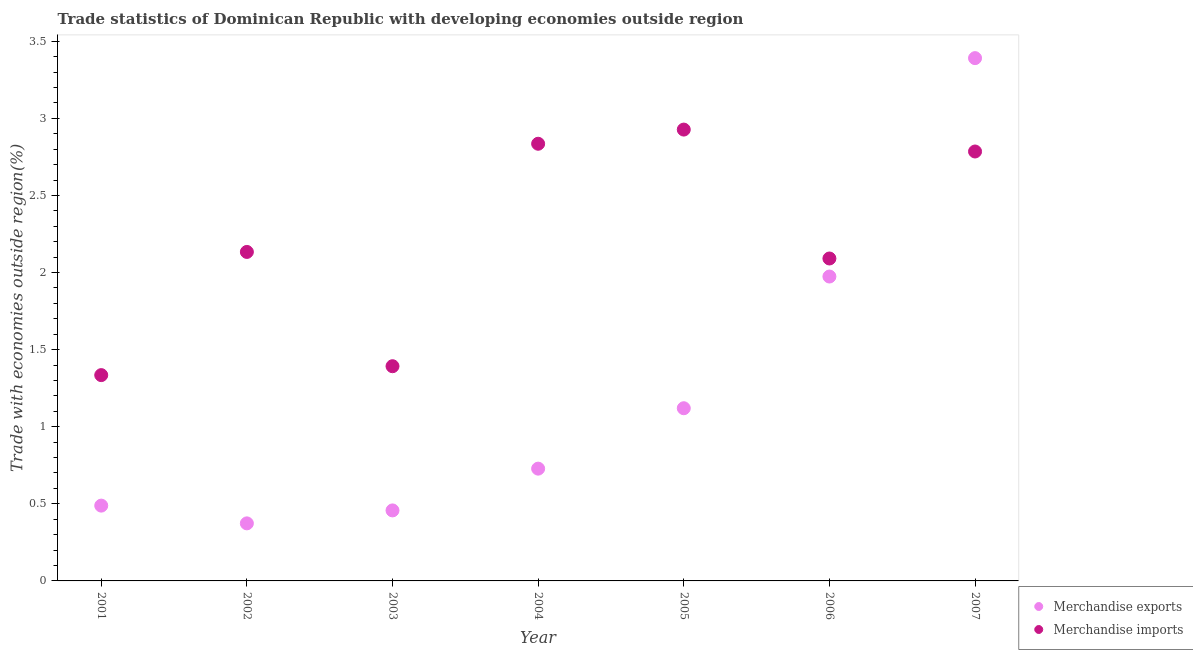How many different coloured dotlines are there?
Offer a terse response. 2. What is the merchandise imports in 2007?
Your answer should be very brief. 2.79. Across all years, what is the maximum merchandise imports?
Offer a terse response. 2.93. Across all years, what is the minimum merchandise exports?
Provide a short and direct response. 0.37. In which year was the merchandise exports minimum?
Your answer should be very brief. 2002. What is the total merchandise exports in the graph?
Keep it short and to the point. 8.53. What is the difference between the merchandise exports in 2004 and that in 2007?
Your answer should be compact. -2.66. What is the difference between the merchandise imports in 2002 and the merchandise exports in 2004?
Your response must be concise. 1.41. What is the average merchandise exports per year?
Your answer should be compact. 1.22. In the year 2001, what is the difference between the merchandise imports and merchandise exports?
Give a very brief answer. 0.85. What is the ratio of the merchandise exports in 2001 to that in 2006?
Ensure brevity in your answer.  0.25. Is the merchandise imports in 2003 less than that in 2005?
Your answer should be compact. Yes. Is the difference between the merchandise imports in 2003 and 2005 greater than the difference between the merchandise exports in 2003 and 2005?
Ensure brevity in your answer.  No. What is the difference between the highest and the second highest merchandise exports?
Provide a succinct answer. 1.42. What is the difference between the highest and the lowest merchandise exports?
Provide a short and direct response. 3.02. In how many years, is the merchandise exports greater than the average merchandise exports taken over all years?
Provide a short and direct response. 2. Is the sum of the merchandise exports in 2002 and 2007 greater than the maximum merchandise imports across all years?
Ensure brevity in your answer.  Yes. Does the merchandise exports monotonically increase over the years?
Keep it short and to the point. No. Is the merchandise imports strictly less than the merchandise exports over the years?
Keep it short and to the point. No. What is the difference between two consecutive major ticks on the Y-axis?
Offer a very short reply. 0.5. Are the values on the major ticks of Y-axis written in scientific E-notation?
Your answer should be compact. No. Does the graph contain grids?
Offer a terse response. No. How many legend labels are there?
Your answer should be compact. 2. What is the title of the graph?
Your response must be concise. Trade statistics of Dominican Republic with developing economies outside region. What is the label or title of the X-axis?
Your answer should be compact. Year. What is the label or title of the Y-axis?
Ensure brevity in your answer.  Trade with economies outside region(%). What is the Trade with economies outside region(%) in Merchandise exports in 2001?
Offer a very short reply. 0.49. What is the Trade with economies outside region(%) of Merchandise imports in 2001?
Your response must be concise. 1.33. What is the Trade with economies outside region(%) in Merchandise exports in 2002?
Your response must be concise. 0.37. What is the Trade with economies outside region(%) in Merchandise imports in 2002?
Your answer should be compact. 2.13. What is the Trade with economies outside region(%) in Merchandise exports in 2003?
Provide a short and direct response. 0.46. What is the Trade with economies outside region(%) of Merchandise imports in 2003?
Give a very brief answer. 1.39. What is the Trade with economies outside region(%) of Merchandise exports in 2004?
Offer a terse response. 0.73. What is the Trade with economies outside region(%) of Merchandise imports in 2004?
Give a very brief answer. 2.84. What is the Trade with economies outside region(%) of Merchandise exports in 2005?
Keep it short and to the point. 1.12. What is the Trade with economies outside region(%) in Merchandise imports in 2005?
Your response must be concise. 2.93. What is the Trade with economies outside region(%) of Merchandise exports in 2006?
Your answer should be compact. 1.97. What is the Trade with economies outside region(%) in Merchandise imports in 2006?
Offer a terse response. 2.09. What is the Trade with economies outside region(%) in Merchandise exports in 2007?
Your answer should be very brief. 3.39. What is the Trade with economies outside region(%) of Merchandise imports in 2007?
Your answer should be compact. 2.79. Across all years, what is the maximum Trade with economies outside region(%) in Merchandise exports?
Offer a terse response. 3.39. Across all years, what is the maximum Trade with economies outside region(%) in Merchandise imports?
Your answer should be very brief. 2.93. Across all years, what is the minimum Trade with economies outside region(%) of Merchandise exports?
Your answer should be compact. 0.37. Across all years, what is the minimum Trade with economies outside region(%) in Merchandise imports?
Keep it short and to the point. 1.33. What is the total Trade with economies outside region(%) of Merchandise exports in the graph?
Your answer should be very brief. 8.53. What is the total Trade with economies outside region(%) of Merchandise imports in the graph?
Provide a short and direct response. 15.5. What is the difference between the Trade with economies outside region(%) of Merchandise exports in 2001 and that in 2002?
Offer a very short reply. 0.12. What is the difference between the Trade with economies outside region(%) in Merchandise imports in 2001 and that in 2002?
Keep it short and to the point. -0.8. What is the difference between the Trade with economies outside region(%) in Merchandise exports in 2001 and that in 2003?
Provide a succinct answer. 0.03. What is the difference between the Trade with economies outside region(%) in Merchandise imports in 2001 and that in 2003?
Your answer should be very brief. -0.06. What is the difference between the Trade with economies outside region(%) in Merchandise exports in 2001 and that in 2004?
Make the answer very short. -0.24. What is the difference between the Trade with economies outside region(%) in Merchandise imports in 2001 and that in 2004?
Offer a terse response. -1.5. What is the difference between the Trade with economies outside region(%) of Merchandise exports in 2001 and that in 2005?
Your response must be concise. -0.63. What is the difference between the Trade with economies outside region(%) in Merchandise imports in 2001 and that in 2005?
Provide a short and direct response. -1.59. What is the difference between the Trade with economies outside region(%) of Merchandise exports in 2001 and that in 2006?
Offer a terse response. -1.49. What is the difference between the Trade with economies outside region(%) in Merchandise imports in 2001 and that in 2006?
Provide a succinct answer. -0.76. What is the difference between the Trade with economies outside region(%) in Merchandise exports in 2001 and that in 2007?
Give a very brief answer. -2.9. What is the difference between the Trade with economies outside region(%) in Merchandise imports in 2001 and that in 2007?
Make the answer very short. -1.45. What is the difference between the Trade with economies outside region(%) of Merchandise exports in 2002 and that in 2003?
Offer a terse response. -0.08. What is the difference between the Trade with economies outside region(%) in Merchandise imports in 2002 and that in 2003?
Give a very brief answer. 0.74. What is the difference between the Trade with economies outside region(%) of Merchandise exports in 2002 and that in 2004?
Offer a terse response. -0.35. What is the difference between the Trade with economies outside region(%) in Merchandise imports in 2002 and that in 2004?
Your answer should be compact. -0.7. What is the difference between the Trade with economies outside region(%) in Merchandise exports in 2002 and that in 2005?
Provide a succinct answer. -0.75. What is the difference between the Trade with economies outside region(%) in Merchandise imports in 2002 and that in 2005?
Your answer should be compact. -0.79. What is the difference between the Trade with economies outside region(%) of Merchandise exports in 2002 and that in 2006?
Ensure brevity in your answer.  -1.6. What is the difference between the Trade with economies outside region(%) in Merchandise imports in 2002 and that in 2006?
Your answer should be very brief. 0.04. What is the difference between the Trade with economies outside region(%) of Merchandise exports in 2002 and that in 2007?
Provide a succinct answer. -3.02. What is the difference between the Trade with economies outside region(%) in Merchandise imports in 2002 and that in 2007?
Your answer should be compact. -0.65. What is the difference between the Trade with economies outside region(%) of Merchandise exports in 2003 and that in 2004?
Offer a very short reply. -0.27. What is the difference between the Trade with economies outside region(%) of Merchandise imports in 2003 and that in 2004?
Offer a very short reply. -1.44. What is the difference between the Trade with economies outside region(%) of Merchandise exports in 2003 and that in 2005?
Your response must be concise. -0.66. What is the difference between the Trade with economies outside region(%) of Merchandise imports in 2003 and that in 2005?
Offer a very short reply. -1.53. What is the difference between the Trade with economies outside region(%) in Merchandise exports in 2003 and that in 2006?
Make the answer very short. -1.52. What is the difference between the Trade with economies outside region(%) of Merchandise imports in 2003 and that in 2006?
Keep it short and to the point. -0.7. What is the difference between the Trade with economies outside region(%) of Merchandise exports in 2003 and that in 2007?
Your response must be concise. -2.93. What is the difference between the Trade with economies outside region(%) of Merchandise imports in 2003 and that in 2007?
Keep it short and to the point. -1.39. What is the difference between the Trade with economies outside region(%) in Merchandise exports in 2004 and that in 2005?
Ensure brevity in your answer.  -0.39. What is the difference between the Trade with economies outside region(%) of Merchandise imports in 2004 and that in 2005?
Ensure brevity in your answer.  -0.09. What is the difference between the Trade with economies outside region(%) of Merchandise exports in 2004 and that in 2006?
Provide a short and direct response. -1.25. What is the difference between the Trade with economies outside region(%) in Merchandise imports in 2004 and that in 2006?
Ensure brevity in your answer.  0.74. What is the difference between the Trade with economies outside region(%) in Merchandise exports in 2004 and that in 2007?
Provide a short and direct response. -2.66. What is the difference between the Trade with economies outside region(%) in Merchandise imports in 2004 and that in 2007?
Keep it short and to the point. 0.05. What is the difference between the Trade with economies outside region(%) in Merchandise exports in 2005 and that in 2006?
Provide a succinct answer. -0.85. What is the difference between the Trade with economies outside region(%) in Merchandise imports in 2005 and that in 2006?
Offer a terse response. 0.84. What is the difference between the Trade with economies outside region(%) in Merchandise exports in 2005 and that in 2007?
Provide a succinct answer. -2.27. What is the difference between the Trade with economies outside region(%) in Merchandise imports in 2005 and that in 2007?
Ensure brevity in your answer.  0.14. What is the difference between the Trade with economies outside region(%) in Merchandise exports in 2006 and that in 2007?
Offer a terse response. -1.42. What is the difference between the Trade with economies outside region(%) of Merchandise imports in 2006 and that in 2007?
Make the answer very short. -0.69. What is the difference between the Trade with economies outside region(%) in Merchandise exports in 2001 and the Trade with economies outside region(%) in Merchandise imports in 2002?
Ensure brevity in your answer.  -1.65. What is the difference between the Trade with economies outside region(%) of Merchandise exports in 2001 and the Trade with economies outside region(%) of Merchandise imports in 2003?
Keep it short and to the point. -0.9. What is the difference between the Trade with economies outside region(%) in Merchandise exports in 2001 and the Trade with economies outside region(%) in Merchandise imports in 2004?
Keep it short and to the point. -2.35. What is the difference between the Trade with economies outside region(%) in Merchandise exports in 2001 and the Trade with economies outside region(%) in Merchandise imports in 2005?
Provide a succinct answer. -2.44. What is the difference between the Trade with economies outside region(%) in Merchandise exports in 2001 and the Trade with economies outside region(%) in Merchandise imports in 2006?
Offer a terse response. -1.6. What is the difference between the Trade with economies outside region(%) of Merchandise exports in 2001 and the Trade with economies outside region(%) of Merchandise imports in 2007?
Your response must be concise. -2.3. What is the difference between the Trade with economies outside region(%) in Merchandise exports in 2002 and the Trade with economies outside region(%) in Merchandise imports in 2003?
Make the answer very short. -1.02. What is the difference between the Trade with economies outside region(%) in Merchandise exports in 2002 and the Trade with economies outside region(%) in Merchandise imports in 2004?
Ensure brevity in your answer.  -2.46. What is the difference between the Trade with economies outside region(%) of Merchandise exports in 2002 and the Trade with economies outside region(%) of Merchandise imports in 2005?
Keep it short and to the point. -2.55. What is the difference between the Trade with economies outside region(%) of Merchandise exports in 2002 and the Trade with economies outside region(%) of Merchandise imports in 2006?
Ensure brevity in your answer.  -1.72. What is the difference between the Trade with economies outside region(%) of Merchandise exports in 2002 and the Trade with economies outside region(%) of Merchandise imports in 2007?
Provide a succinct answer. -2.41. What is the difference between the Trade with economies outside region(%) in Merchandise exports in 2003 and the Trade with economies outside region(%) in Merchandise imports in 2004?
Your response must be concise. -2.38. What is the difference between the Trade with economies outside region(%) in Merchandise exports in 2003 and the Trade with economies outside region(%) in Merchandise imports in 2005?
Your response must be concise. -2.47. What is the difference between the Trade with economies outside region(%) of Merchandise exports in 2003 and the Trade with economies outside region(%) of Merchandise imports in 2006?
Your answer should be compact. -1.63. What is the difference between the Trade with economies outside region(%) of Merchandise exports in 2003 and the Trade with economies outside region(%) of Merchandise imports in 2007?
Make the answer very short. -2.33. What is the difference between the Trade with economies outside region(%) of Merchandise exports in 2004 and the Trade with economies outside region(%) of Merchandise imports in 2005?
Offer a very short reply. -2.2. What is the difference between the Trade with economies outside region(%) of Merchandise exports in 2004 and the Trade with economies outside region(%) of Merchandise imports in 2006?
Keep it short and to the point. -1.36. What is the difference between the Trade with economies outside region(%) in Merchandise exports in 2004 and the Trade with economies outside region(%) in Merchandise imports in 2007?
Make the answer very short. -2.06. What is the difference between the Trade with economies outside region(%) in Merchandise exports in 2005 and the Trade with economies outside region(%) in Merchandise imports in 2006?
Your answer should be very brief. -0.97. What is the difference between the Trade with economies outside region(%) of Merchandise exports in 2005 and the Trade with economies outside region(%) of Merchandise imports in 2007?
Give a very brief answer. -1.67. What is the difference between the Trade with economies outside region(%) of Merchandise exports in 2006 and the Trade with economies outside region(%) of Merchandise imports in 2007?
Provide a succinct answer. -0.81. What is the average Trade with economies outside region(%) of Merchandise exports per year?
Offer a terse response. 1.22. What is the average Trade with economies outside region(%) in Merchandise imports per year?
Offer a terse response. 2.21. In the year 2001, what is the difference between the Trade with economies outside region(%) in Merchandise exports and Trade with economies outside region(%) in Merchandise imports?
Keep it short and to the point. -0.85. In the year 2002, what is the difference between the Trade with economies outside region(%) of Merchandise exports and Trade with economies outside region(%) of Merchandise imports?
Keep it short and to the point. -1.76. In the year 2003, what is the difference between the Trade with economies outside region(%) in Merchandise exports and Trade with economies outside region(%) in Merchandise imports?
Offer a very short reply. -0.94. In the year 2004, what is the difference between the Trade with economies outside region(%) in Merchandise exports and Trade with economies outside region(%) in Merchandise imports?
Make the answer very short. -2.11. In the year 2005, what is the difference between the Trade with economies outside region(%) in Merchandise exports and Trade with economies outside region(%) in Merchandise imports?
Your answer should be compact. -1.81. In the year 2006, what is the difference between the Trade with economies outside region(%) of Merchandise exports and Trade with economies outside region(%) of Merchandise imports?
Provide a succinct answer. -0.12. In the year 2007, what is the difference between the Trade with economies outside region(%) of Merchandise exports and Trade with economies outside region(%) of Merchandise imports?
Keep it short and to the point. 0.61. What is the ratio of the Trade with economies outside region(%) of Merchandise exports in 2001 to that in 2002?
Provide a short and direct response. 1.31. What is the ratio of the Trade with economies outside region(%) in Merchandise imports in 2001 to that in 2002?
Give a very brief answer. 0.63. What is the ratio of the Trade with economies outside region(%) in Merchandise exports in 2001 to that in 2003?
Keep it short and to the point. 1.07. What is the ratio of the Trade with economies outside region(%) in Merchandise imports in 2001 to that in 2003?
Offer a very short reply. 0.96. What is the ratio of the Trade with economies outside region(%) of Merchandise exports in 2001 to that in 2004?
Ensure brevity in your answer.  0.67. What is the ratio of the Trade with economies outside region(%) in Merchandise imports in 2001 to that in 2004?
Provide a short and direct response. 0.47. What is the ratio of the Trade with economies outside region(%) in Merchandise exports in 2001 to that in 2005?
Your answer should be compact. 0.44. What is the ratio of the Trade with economies outside region(%) of Merchandise imports in 2001 to that in 2005?
Provide a succinct answer. 0.46. What is the ratio of the Trade with economies outside region(%) in Merchandise exports in 2001 to that in 2006?
Provide a succinct answer. 0.25. What is the ratio of the Trade with economies outside region(%) of Merchandise imports in 2001 to that in 2006?
Give a very brief answer. 0.64. What is the ratio of the Trade with economies outside region(%) of Merchandise exports in 2001 to that in 2007?
Provide a short and direct response. 0.14. What is the ratio of the Trade with economies outside region(%) of Merchandise imports in 2001 to that in 2007?
Provide a short and direct response. 0.48. What is the ratio of the Trade with economies outside region(%) in Merchandise exports in 2002 to that in 2003?
Your response must be concise. 0.82. What is the ratio of the Trade with economies outside region(%) in Merchandise imports in 2002 to that in 2003?
Keep it short and to the point. 1.53. What is the ratio of the Trade with economies outside region(%) in Merchandise exports in 2002 to that in 2004?
Keep it short and to the point. 0.51. What is the ratio of the Trade with economies outside region(%) in Merchandise imports in 2002 to that in 2004?
Provide a succinct answer. 0.75. What is the ratio of the Trade with economies outside region(%) of Merchandise exports in 2002 to that in 2005?
Provide a short and direct response. 0.33. What is the ratio of the Trade with economies outside region(%) in Merchandise imports in 2002 to that in 2005?
Your answer should be very brief. 0.73. What is the ratio of the Trade with economies outside region(%) of Merchandise exports in 2002 to that in 2006?
Make the answer very short. 0.19. What is the ratio of the Trade with economies outside region(%) of Merchandise imports in 2002 to that in 2006?
Provide a succinct answer. 1.02. What is the ratio of the Trade with economies outside region(%) in Merchandise exports in 2002 to that in 2007?
Your answer should be very brief. 0.11. What is the ratio of the Trade with economies outside region(%) in Merchandise imports in 2002 to that in 2007?
Provide a short and direct response. 0.77. What is the ratio of the Trade with economies outside region(%) in Merchandise exports in 2003 to that in 2004?
Keep it short and to the point. 0.63. What is the ratio of the Trade with economies outside region(%) in Merchandise imports in 2003 to that in 2004?
Provide a short and direct response. 0.49. What is the ratio of the Trade with economies outside region(%) in Merchandise exports in 2003 to that in 2005?
Provide a succinct answer. 0.41. What is the ratio of the Trade with economies outside region(%) of Merchandise imports in 2003 to that in 2005?
Your answer should be compact. 0.48. What is the ratio of the Trade with economies outside region(%) in Merchandise exports in 2003 to that in 2006?
Your response must be concise. 0.23. What is the ratio of the Trade with economies outside region(%) of Merchandise imports in 2003 to that in 2006?
Provide a short and direct response. 0.67. What is the ratio of the Trade with economies outside region(%) in Merchandise exports in 2003 to that in 2007?
Ensure brevity in your answer.  0.13. What is the ratio of the Trade with economies outside region(%) in Merchandise exports in 2004 to that in 2005?
Offer a terse response. 0.65. What is the ratio of the Trade with economies outside region(%) of Merchandise imports in 2004 to that in 2005?
Provide a succinct answer. 0.97. What is the ratio of the Trade with economies outside region(%) of Merchandise exports in 2004 to that in 2006?
Your answer should be compact. 0.37. What is the ratio of the Trade with economies outside region(%) in Merchandise imports in 2004 to that in 2006?
Your response must be concise. 1.36. What is the ratio of the Trade with economies outside region(%) of Merchandise exports in 2004 to that in 2007?
Make the answer very short. 0.21. What is the ratio of the Trade with economies outside region(%) in Merchandise imports in 2004 to that in 2007?
Your answer should be compact. 1.02. What is the ratio of the Trade with economies outside region(%) in Merchandise exports in 2005 to that in 2006?
Your answer should be compact. 0.57. What is the ratio of the Trade with economies outside region(%) of Merchandise imports in 2005 to that in 2006?
Provide a short and direct response. 1.4. What is the ratio of the Trade with economies outside region(%) of Merchandise exports in 2005 to that in 2007?
Offer a terse response. 0.33. What is the ratio of the Trade with economies outside region(%) in Merchandise imports in 2005 to that in 2007?
Provide a succinct answer. 1.05. What is the ratio of the Trade with economies outside region(%) of Merchandise exports in 2006 to that in 2007?
Keep it short and to the point. 0.58. What is the ratio of the Trade with economies outside region(%) in Merchandise imports in 2006 to that in 2007?
Provide a succinct answer. 0.75. What is the difference between the highest and the second highest Trade with economies outside region(%) in Merchandise exports?
Your answer should be compact. 1.42. What is the difference between the highest and the second highest Trade with economies outside region(%) of Merchandise imports?
Offer a terse response. 0.09. What is the difference between the highest and the lowest Trade with economies outside region(%) in Merchandise exports?
Your response must be concise. 3.02. What is the difference between the highest and the lowest Trade with economies outside region(%) in Merchandise imports?
Your response must be concise. 1.59. 